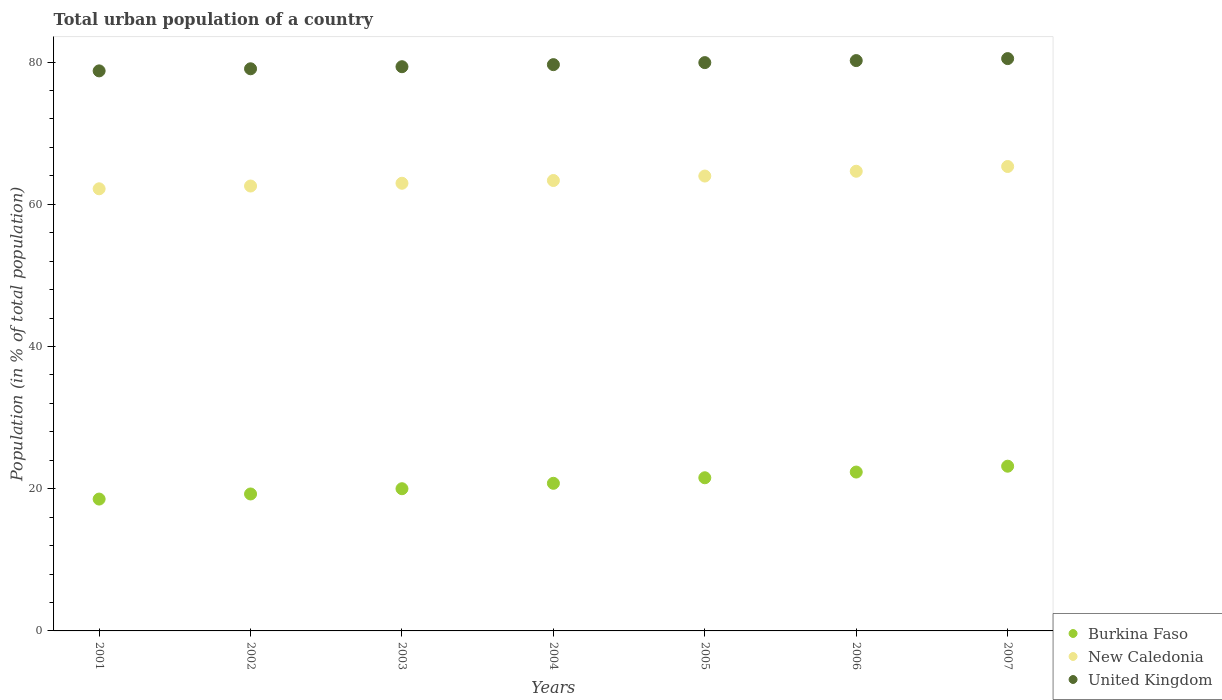How many different coloured dotlines are there?
Keep it short and to the point. 3. Is the number of dotlines equal to the number of legend labels?
Keep it short and to the point. Yes. What is the urban population in Burkina Faso in 2006?
Give a very brief answer. 22.34. Across all years, what is the maximum urban population in New Caledonia?
Provide a short and direct response. 65.31. Across all years, what is the minimum urban population in New Caledonia?
Give a very brief answer. 62.17. What is the total urban population in United Kingdom in the graph?
Your answer should be compact. 557.36. What is the difference between the urban population in United Kingdom in 2005 and that in 2007?
Give a very brief answer. -0.56. What is the difference between the urban population in United Kingdom in 2001 and the urban population in New Caledonia in 2007?
Your answer should be compact. 13.45. What is the average urban population in New Caledonia per year?
Your answer should be compact. 63.56. In the year 2003, what is the difference between the urban population in Burkina Faso and urban population in United Kingdom?
Give a very brief answer. -59.34. In how many years, is the urban population in New Caledonia greater than 72 %?
Your answer should be very brief. 0. What is the ratio of the urban population in Burkina Faso in 2002 to that in 2007?
Keep it short and to the point. 0.83. What is the difference between the highest and the second highest urban population in United Kingdom?
Ensure brevity in your answer.  0.28. What is the difference between the highest and the lowest urban population in New Caledonia?
Your answer should be very brief. 3.13. Is it the case that in every year, the sum of the urban population in Burkina Faso and urban population in United Kingdom  is greater than the urban population in New Caledonia?
Offer a terse response. Yes. Is the urban population in United Kingdom strictly greater than the urban population in New Caledonia over the years?
Your answer should be compact. Yes. Are the values on the major ticks of Y-axis written in scientific E-notation?
Ensure brevity in your answer.  No. How many legend labels are there?
Make the answer very short. 3. What is the title of the graph?
Your answer should be very brief. Total urban population of a country. What is the label or title of the X-axis?
Provide a succinct answer. Years. What is the label or title of the Y-axis?
Keep it short and to the point. Population (in % of total population). What is the Population (in % of total population) in Burkina Faso in 2001?
Ensure brevity in your answer.  18.54. What is the Population (in % of total population) in New Caledonia in 2001?
Provide a succinct answer. 62.17. What is the Population (in % of total population) in United Kingdom in 2001?
Provide a short and direct response. 78.75. What is the Population (in % of total population) in Burkina Faso in 2002?
Make the answer very short. 19.26. What is the Population (in % of total population) in New Caledonia in 2002?
Offer a terse response. 62.56. What is the Population (in % of total population) of United Kingdom in 2002?
Provide a succinct answer. 79.05. What is the Population (in % of total population) of Burkina Faso in 2003?
Provide a short and direct response. 20. What is the Population (in % of total population) of New Caledonia in 2003?
Your answer should be very brief. 62.95. What is the Population (in % of total population) of United Kingdom in 2003?
Your answer should be compact. 79.34. What is the Population (in % of total population) in Burkina Faso in 2004?
Give a very brief answer. 20.76. What is the Population (in % of total population) in New Caledonia in 2004?
Offer a terse response. 63.34. What is the Population (in % of total population) in United Kingdom in 2004?
Give a very brief answer. 79.63. What is the Population (in % of total population) in Burkina Faso in 2005?
Ensure brevity in your answer.  21.54. What is the Population (in % of total population) in New Caledonia in 2005?
Make the answer very short. 63.97. What is the Population (in % of total population) of United Kingdom in 2005?
Keep it short and to the point. 79.92. What is the Population (in % of total population) of Burkina Faso in 2006?
Provide a short and direct response. 22.34. What is the Population (in % of total population) of New Caledonia in 2006?
Offer a terse response. 64.64. What is the Population (in % of total population) of United Kingdom in 2006?
Your answer should be compact. 80.2. What is the Population (in % of total population) in Burkina Faso in 2007?
Your response must be concise. 23.16. What is the Population (in % of total population) in New Caledonia in 2007?
Give a very brief answer. 65.31. What is the Population (in % of total population) in United Kingdom in 2007?
Your answer should be very brief. 80.48. Across all years, what is the maximum Population (in % of total population) of Burkina Faso?
Keep it short and to the point. 23.16. Across all years, what is the maximum Population (in % of total population) in New Caledonia?
Provide a succinct answer. 65.31. Across all years, what is the maximum Population (in % of total population) of United Kingdom?
Your response must be concise. 80.48. Across all years, what is the minimum Population (in % of total population) of Burkina Faso?
Your answer should be compact. 18.54. Across all years, what is the minimum Population (in % of total population) of New Caledonia?
Offer a very short reply. 62.17. Across all years, what is the minimum Population (in % of total population) of United Kingdom?
Make the answer very short. 78.75. What is the total Population (in % of total population) of Burkina Faso in the graph?
Ensure brevity in your answer.  145.59. What is the total Population (in % of total population) of New Caledonia in the graph?
Your answer should be very brief. 444.93. What is the total Population (in % of total population) in United Kingdom in the graph?
Your answer should be very brief. 557.36. What is the difference between the Population (in % of total population) in Burkina Faso in 2001 and that in 2002?
Make the answer very short. -0.72. What is the difference between the Population (in % of total population) in New Caledonia in 2001 and that in 2002?
Your answer should be compact. -0.39. What is the difference between the Population (in % of total population) in United Kingdom in 2001 and that in 2002?
Offer a very short reply. -0.3. What is the difference between the Population (in % of total population) of Burkina Faso in 2001 and that in 2003?
Provide a succinct answer. -1.46. What is the difference between the Population (in % of total population) in New Caledonia in 2001 and that in 2003?
Give a very brief answer. -0.78. What is the difference between the Population (in % of total population) of United Kingdom in 2001 and that in 2003?
Keep it short and to the point. -0.59. What is the difference between the Population (in % of total population) in Burkina Faso in 2001 and that in 2004?
Give a very brief answer. -2.22. What is the difference between the Population (in % of total population) in New Caledonia in 2001 and that in 2004?
Your answer should be very brief. -1.17. What is the difference between the Population (in % of total population) in United Kingdom in 2001 and that in 2004?
Keep it short and to the point. -0.88. What is the difference between the Population (in % of total population) of Burkina Faso in 2001 and that in 2005?
Offer a terse response. -3. What is the difference between the Population (in % of total population) in New Caledonia in 2001 and that in 2005?
Make the answer very short. -1.79. What is the difference between the Population (in % of total population) in United Kingdom in 2001 and that in 2005?
Offer a very short reply. -1.16. What is the difference between the Population (in % of total population) in Burkina Faso in 2001 and that in 2006?
Your answer should be very brief. -3.8. What is the difference between the Population (in % of total population) in New Caledonia in 2001 and that in 2006?
Make the answer very short. -2.47. What is the difference between the Population (in % of total population) in United Kingdom in 2001 and that in 2006?
Ensure brevity in your answer.  -1.45. What is the difference between the Population (in % of total population) of Burkina Faso in 2001 and that in 2007?
Keep it short and to the point. -4.62. What is the difference between the Population (in % of total population) in New Caledonia in 2001 and that in 2007?
Keep it short and to the point. -3.13. What is the difference between the Population (in % of total population) of United Kingdom in 2001 and that in 2007?
Provide a short and direct response. -1.73. What is the difference between the Population (in % of total population) in Burkina Faso in 2002 and that in 2003?
Offer a terse response. -0.74. What is the difference between the Population (in % of total population) of New Caledonia in 2002 and that in 2003?
Offer a terse response. -0.39. What is the difference between the Population (in % of total population) of United Kingdom in 2002 and that in 2003?
Your answer should be compact. -0.29. What is the difference between the Population (in % of total population) of Burkina Faso in 2002 and that in 2004?
Your answer should be very brief. -1.5. What is the difference between the Population (in % of total population) in New Caledonia in 2002 and that in 2004?
Ensure brevity in your answer.  -0.78. What is the difference between the Population (in % of total population) of United Kingdom in 2002 and that in 2004?
Give a very brief answer. -0.58. What is the difference between the Population (in % of total population) in Burkina Faso in 2002 and that in 2005?
Your response must be concise. -2.28. What is the difference between the Population (in % of total population) in New Caledonia in 2002 and that in 2005?
Your answer should be very brief. -1.4. What is the difference between the Population (in % of total population) of United Kingdom in 2002 and that in 2005?
Give a very brief answer. -0.87. What is the difference between the Population (in % of total population) of Burkina Faso in 2002 and that in 2006?
Your response must be concise. -3.08. What is the difference between the Population (in % of total population) of New Caledonia in 2002 and that in 2006?
Provide a short and direct response. -2.08. What is the difference between the Population (in % of total population) in United Kingdom in 2002 and that in 2006?
Your answer should be compact. -1.15. What is the difference between the Population (in % of total population) of Burkina Faso in 2002 and that in 2007?
Provide a succinct answer. -3.9. What is the difference between the Population (in % of total population) of New Caledonia in 2002 and that in 2007?
Your response must be concise. -2.75. What is the difference between the Population (in % of total population) in United Kingdom in 2002 and that in 2007?
Offer a terse response. -1.43. What is the difference between the Population (in % of total population) in Burkina Faso in 2003 and that in 2004?
Your response must be concise. -0.76. What is the difference between the Population (in % of total population) in New Caledonia in 2003 and that in 2004?
Offer a terse response. -0.39. What is the difference between the Population (in % of total population) in United Kingdom in 2003 and that in 2004?
Make the answer very short. -0.29. What is the difference between the Population (in % of total population) in Burkina Faso in 2003 and that in 2005?
Give a very brief answer. -1.54. What is the difference between the Population (in % of total population) in New Caledonia in 2003 and that in 2005?
Your answer should be very brief. -1.02. What is the difference between the Population (in % of total population) of United Kingdom in 2003 and that in 2005?
Make the answer very short. -0.58. What is the difference between the Population (in % of total population) in Burkina Faso in 2003 and that in 2006?
Keep it short and to the point. -2.34. What is the difference between the Population (in % of total population) of New Caledonia in 2003 and that in 2006?
Offer a terse response. -1.69. What is the difference between the Population (in % of total population) of United Kingdom in 2003 and that in 2006?
Give a very brief answer. -0.86. What is the difference between the Population (in % of total population) of Burkina Faso in 2003 and that in 2007?
Keep it short and to the point. -3.17. What is the difference between the Population (in % of total population) of New Caledonia in 2003 and that in 2007?
Offer a terse response. -2.36. What is the difference between the Population (in % of total population) of United Kingdom in 2003 and that in 2007?
Offer a terse response. -1.14. What is the difference between the Population (in % of total population) in Burkina Faso in 2004 and that in 2005?
Your answer should be compact. -0.78. What is the difference between the Population (in % of total population) of New Caledonia in 2004 and that in 2005?
Your answer should be very brief. -0.63. What is the difference between the Population (in % of total population) in United Kingdom in 2004 and that in 2005?
Your response must be concise. -0.29. What is the difference between the Population (in % of total population) in Burkina Faso in 2004 and that in 2006?
Your answer should be compact. -1.58. What is the difference between the Population (in % of total population) of New Caledonia in 2004 and that in 2006?
Your answer should be compact. -1.3. What is the difference between the Population (in % of total population) of United Kingdom in 2004 and that in 2006?
Provide a short and direct response. -0.57. What is the difference between the Population (in % of total population) in Burkina Faso in 2004 and that in 2007?
Offer a very short reply. -2.41. What is the difference between the Population (in % of total population) of New Caledonia in 2004 and that in 2007?
Offer a terse response. -1.97. What is the difference between the Population (in % of total population) of United Kingdom in 2004 and that in 2007?
Your answer should be very brief. -0.85. What is the difference between the Population (in % of total population) in Burkina Faso in 2005 and that in 2006?
Offer a terse response. -0.8. What is the difference between the Population (in % of total population) in New Caledonia in 2005 and that in 2006?
Offer a very short reply. -0.67. What is the difference between the Population (in % of total population) in United Kingdom in 2005 and that in 2006?
Offer a terse response. -0.28. What is the difference between the Population (in % of total population) of Burkina Faso in 2005 and that in 2007?
Provide a succinct answer. -1.63. What is the difference between the Population (in % of total population) of New Caledonia in 2005 and that in 2007?
Your answer should be very brief. -1.34. What is the difference between the Population (in % of total population) in United Kingdom in 2005 and that in 2007?
Provide a short and direct response. -0.56. What is the difference between the Population (in % of total population) of Burkina Faso in 2006 and that in 2007?
Offer a very short reply. -0.82. What is the difference between the Population (in % of total population) in New Caledonia in 2006 and that in 2007?
Keep it short and to the point. -0.67. What is the difference between the Population (in % of total population) of United Kingdom in 2006 and that in 2007?
Keep it short and to the point. -0.28. What is the difference between the Population (in % of total population) in Burkina Faso in 2001 and the Population (in % of total population) in New Caledonia in 2002?
Offer a very short reply. -44.02. What is the difference between the Population (in % of total population) in Burkina Faso in 2001 and the Population (in % of total population) in United Kingdom in 2002?
Offer a very short reply. -60.51. What is the difference between the Population (in % of total population) in New Caledonia in 2001 and the Population (in % of total population) in United Kingdom in 2002?
Make the answer very short. -16.88. What is the difference between the Population (in % of total population) in Burkina Faso in 2001 and the Population (in % of total population) in New Caledonia in 2003?
Offer a terse response. -44.41. What is the difference between the Population (in % of total population) in Burkina Faso in 2001 and the Population (in % of total population) in United Kingdom in 2003?
Make the answer very short. -60.8. What is the difference between the Population (in % of total population) in New Caledonia in 2001 and the Population (in % of total population) in United Kingdom in 2003?
Offer a terse response. -17.17. What is the difference between the Population (in % of total population) of Burkina Faso in 2001 and the Population (in % of total population) of New Caledonia in 2004?
Offer a very short reply. -44.8. What is the difference between the Population (in % of total population) of Burkina Faso in 2001 and the Population (in % of total population) of United Kingdom in 2004?
Your answer should be compact. -61.09. What is the difference between the Population (in % of total population) in New Caledonia in 2001 and the Population (in % of total population) in United Kingdom in 2004?
Your answer should be compact. -17.46. What is the difference between the Population (in % of total population) of Burkina Faso in 2001 and the Population (in % of total population) of New Caledonia in 2005?
Ensure brevity in your answer.  -45.42. What is the difference between the Population (in % of total population) in Burkina Faso in 2001 and the Population (in % of total population) in United Kingdom in 2005?
Your answer should be compact. -61.38. What is the difference between the Population (in % of total population) of New Caledonia in 2001 and the Population (in % of total population) of United Kingdom in 2005?
Keep it short and to the point. -17.74. What is the difference between the Population (in % of total population) in Burkina Faso in 2001 and the Population (in % of total population) in New Caledonia in 2006?
Ensure brevity in your answer.  -46.1. What is the difference between the Population (in % of total population) of Burkina Faso in 2001 and the Population (in % of total population) of United Kingdom in 2006?
Your response must be concise. -61.66. What is the difference between the Population (in % of total population) in New Caledonia in 2001 and the Population (in % of total population) in United Kingdom in 2006?
Provide a short and direct response. -18.03. What is the difference between the Population (in % of total population) of Burkina Faso in 2001 and the Population (in % of total population) of New Caledonia in 2007?
Ensure brevity in your answer.  -46.77. What is the difference between the Population (in % of total population) of Burkina Faso in 2001 and the Population (in % of total population) of United Kingdom in 2007?
Ensure brevity in your answer.  -61.94. What is the difference between the Population (in % of total population) in New Caledonia in 2001 and the Population (in % of total population) in United Kingdom in 2007?
Offer a terse response. -18.31. What is the difference between the Population (in % of total population) in Burkina Faso in 2002 and the Population (in % of total population) in New Caledonia in 2003?
Offer a terse response. -43.69. What is the difference between the Population (in % of total population) of Burkina Faso in 2002 and the Population (in % of total population) of United Kingdom in 2003?
Keep it short and to the point. -60.08. What is the difference between the Population (in % of total population) in New Caledonia in 2002 and the Population (in % of total population) in United Kingdom in 2003?
Your answer should be compact. -16.78. What is the difference between the Population (in % of total population) of Burkina Faso in 2002 and the Population (in % of total population) of New Caledonia in 2004?
Ensure brevity in your answer.  -44.08. What is the difference between the Population (in % of total population) of Burkina Faso in 2002 and the Population (in % of total population) of United Kingdom in 2004?
Your answer should be compact. -60.37. What is the difference between the Population (in % of total population) in New Caledonia in 2002 and the Population (in % of total population) in United Kingdom in 2004?
Offer a terse response. -17.07. What is the difference between the Population (in % of total population) of Burkina Faso in 2002 and the Population (in % of total population) of New Caledonia in 2005?
Your answer should be compact. -44.71. What is the difference between the Population (in % of total population) of Burkina Faso in 2002 and the Population (in % of total population) of United Kingdom in 2005?
Your answer should be compact. -60.66. What is the difference between the Population (in % of total population) in New Caledonia in 2002 and the Population (in % of total population) in United Kingdom in 2005?
Your response must be concise. -17.35. What is the difference between the Population (in % of total population) of Burkina Faso in 2002 and the Population (in % of total population) of New Caledonia in 2006?
Provide a succinct answer. -45.38. What is the difference between the Population (in % of total population) in Burkina Faso in 2002 and the Population (in % of total population) in United Kingdom in 2006?
Offer a terse response. -60.94. What is the difference between the Population (in % of total population) in New Caledonia in 2002 and the Population (in % of total population) in United Kingdom in 2006?
Your response must be concise. -17.64. What is the difference between the Population (in % of total population) in Burkina Faso in 2002 and the Population (in % of total population) in New Caledonia in 2007?
Ensure brevity in your answer.  -46.05. What is the difference between the Population (in % of total population) in Burkina Faso in 2002 and the Population (in % of total population) in United Kingdom in 2007?
Your answer should be compact. -61.22. What is the difference between the Population (in % of total population) of New Caledonia in 2002 and the Population (in % of total population) of United Kingdom in 2007?
Provide a succinct answer. -17.92. What is the difference between the Population (in % of total population) in Burkina Faso in 2003 and the Population (in % of total population) in New Caledonia in 2004?
Offer a terse response. -43.34. What is the difference between the Population (in % of total population) of Burkina Faso in 2003 and the Population (in % of total population) of United Kingdom in 2004?
Keep it short and to the point. -59.63. What is the difference between the Population (in % of total population) of New Caledonia in 2003 and the Population (in % of total population) of United Kingdom in 2004?
Your response must be concise. -16.68. What is the difference between the Population (in % of total population) of Burkina Faso in 2003 and the Population (in % of total population) of New Caledonia in 2005?
Provide a succinct answer. -43.97. What is the difference between the Population (in % of total population) in Burkina Faso in 2003 and the Population (in % of total population) in United Kingdom in 2005?
Your response must be concise. -59.92. What is the difference between the Population (in % of total population) of New Caledonia in 2003 and the Population (in % of total population) of United Kingdom in 2005?
Your answer should be very brief. -16.97. What is the difference between the Population (in % of total population) of Burkina Faso in 2003 and the Population (in % of total population) of New Caledonia in 2006?
Make the answer very short. -44.64. What is the difference between the Population (in % of total population) in Burkina Faso in 2003 and the Population (in % of total population) in United Kingdom in 2006?
Offer a very short reply. -60.2. What is the difference between the Population (in % of total population) of New Caledonia in 2003 and the Population (in % of total population) of United Kingdom in 2006?
Your answer should be compact. -17.25. What is the difference between the Population (in % of total population) in Burkina Faso in 2003 and the Population (in % of total population) in New Caledonia in 2007?
Offer a very short reply. -45.31. What is the difference between the Population (in % of total population) of Burkina Faso in 2003 and the Population (in % of total population) of United Kingdom in 2007?
Give a very brief answer. -60.48. What is the difference between the Population (in % of total population) of New Caledonia in 2003 and the Population (in % of total population) of United Kingdom in 2007?
Keep it short and to the point. -17.53. What is the difference between the Population (in % of total population) of Burkina Faso in 2004 and the Population (in % of total population) of New Caledonia in 2005?
Provide a short and direct response. -43.21. What is the difference between the Population (in % of total population) in Burkina Faso in 2004 and the Population (in % of total population) in United Kingdom in 2005?
Keep it short and to the point. -59.16. What is the difference between the Population (in % of total population) of New Caledonia in 2004 and the Population (in % of total population) of United Kingdom in 2005?
Keep it short and to the point. -16.58. What is the difference between the Population (in % of total population) in Burkina Faso in 2004 and the Population (in % of total population) in New Caledonia in 2006?
Your response must be concise. -43.88. What is the difference between the Population (in % of total population) of Burkina Faso in 2004 and the Population (in % of total population) of United Kingdom in 2006?
Provide a succinct answer. -59.44. What is the difference between the Population (in % of total population) in New Caledonia in 2004 and the Population (in % of total population) in United Kingdom in 2006?
Make the answer very short. -16.86. What is the difference between the Population (in % of total population) of Burkina Faso in 2004 and the Population (in % of total population) of New Caledonia in 2007?
Offer a terse response. -44.55. What is the difference between the Population (in % of total population) in Burkina Faso in 2004 and the Population (in % of total population) in United Kingdom in 2007?
Offer a very short reply. -59.72. What is the difference between the Population (in % of total population) of New Caledonia in 2004 and the Population (in % of total population) of United Kingdom in 2007?
Make the answer very short. -17.14. What is the difference between the Population (in % of total population) of Burkina Faso in 2005 and the Population (in % of total population) of New Caledonia in 2006?
Offer a terse response. -43.1. What is the difference between the Population (in % of total population) of Burkina Faso in 2005 and the Population (in % of total population) of United Kingdom in 2006?
Ensure brevity in your answer.  -58.66. What is the difference between the Population (in % of total population) of New Caledonia in 2005 and the Population (in % of total population) of United Kingdom in 2006?
Provide a succinct answer. -16.23. What is the difference between the Population (in % of total population) in Burkina Faso in 2005 and the Population (in % of total population) in New Caledonia in 2007?
Give a very brief answer. -43.77. What is the difference between the Population (in % of total population) of Burkina Faso in 2005 and the Population (in % of total population) of United Kingdom in 2007?
Make the answer very short. -58.94. What is the difference between the Population (in % of total population) in New Caledonia in 2005 and the Population (in % of total population) in United Kingdom in 2007?
Give a very brief answer. -16.51. What is the difference between the Population (in % of total population) in Burkina Faso in 2006 and the Population (in % of total population) in New Caledonia in 2007?
Give a very brief answer. -42.97. What is the difference between the Population (in % of total population) of Burkina Faso in 2006 and the Population (in % of total population) of United Kingdom in 2007?
Offer a terse response. -58.14. What is the difference between the Population (in % of total population) of New Caledonia in 2006 and the Population (in % of total population) of United Kingdom in 2007?
Make the answer very short. -15.84. What is the average Population (in % of total population) in Burkina Faso per year?
Your response must be concise. 20.8. What is the average Population (in % of total population) of New Caledonia per year?
Give a very brief answer. 63.56. What is the average Population (in % of total population) in United Kingdom per year?
Make the answer very short. 79.62. In the year 2001, what is the difference between the Population (in % of total population) in Burkina Faso and Population (in % of total population) in New Caledonia?
Your answer should be very brief. -43.63. In the year 2001, what is the difference between the Population (in % of total population) of Burkina Faso and Population (in % of total population) of United Kingdom?
Provide a short and direct response. -60.21. In the year 2001, what is the difference between the Population (in % of total population) in New Caledonia and Population (in % of total population) in United Kingdom?
Keep it short and to the point. -16.58. In the year 2002, what is the difference between the Population (in % of total population) of Burkina Faso and Population (in % of total population) of New Caledonia?
Offer a terse response. -43.3. In the year 2002, what is the difference between the Population (in % of total population) in Burkina Faso and Population (in % of total population) in United Kingdom?
Keep it short and to the point. -59.79. In the year 2002, what is the difference between the Population (in % of total population) in New Caledonia and Population (in % of total population) in United Kingdom?
Offer a terse response. -16.49. In the year 2003, what is the difference between the Population (in % of total population) in Burkina Faso and Population (in % of total population) in New Caledonia?
Provide a short and direct response. -42.95. In the year 2003, what is the difference between the Population (in % of total population) in Burkina Faso and Population (in % of total population) in United Kingdom?
Keep it short and to the point. -59.34. In the year 2003, what is the difference between the Population (in % of total population) of New Caledonia and Population (in % of total population) of United Kingdom?
Your answer should be very brief. -16.39. In the year 2004, what is the difference between the Population (in % of total population) in Burkina Faso and Population (in % of total population) in New Caledonia?
Offer a terse response. -42.58. In the year 2004, what is the difference between the Population (in % of total population) in Burkina Faso and Population (in % of total population) in United Kingdom?
Your response must be concise. -58.87. In the year 2004, what is the difference between the Population (in % of total population) in New Caledonia and Population (in % of total population) in United Kingdom?
Your answer should be compact. -16.29. In the year 2005, what is the difference between the Population (in % of total population) of Burkina Faso and Population (in % of total population) of New Caledonia?
Offer a terse response. -42.43. In the year 2005, what is the difference between the Population (in % of total population) in Burkina Faso and Population (in % of total population) in United Kingdom?
Provide a succinct answer. -58.38. In the year 2005, what is the difference between the Population (in % of total population) in New Caledonia and Population (in % of total population) in United Kingdom?
Your answer should be very brief. -15.95. In the year 2006, what is the difference between the Population (in % of total population) in Burkina Faso and Population (in % of total population) in New Caledonia?
Offer a terse response. -42.3. In the year 2006, what is the difference between the Population (in % of total population) in Burkina Faso and Population (in % of total population) in United Kingdom?
Your answer should be very brief. -57.86. In the year 2006, what is the difference between the Population (in % of total population) of New Caledonia and Population (in % of total population) of United Kingdom?
Your answer should be compact. -15.56. In the year 2007, what is the difference between the Population (in % of total population) of Burkina Faso and Population (in % of total population) of New Caledonia?
Offer a terse response. -42.14. In the year 2007, what is the difference between the Population (in % of total population) of Burkina Faso and Population (in % of total population) of United Kingdom?
Your response must be concise. -57.32. In the year 2007, what is the difference between the Population (in % of total population) in New Caledonia and Population (in % of total population) in United Kingdom?
Ensure brevity in your answer.  -15.17. What is the ratio of the Population (in % of total population) of Burkina Faso in 2001 to that in 2002?
Offer a terse response. 0.96. What is the ratio of the Population (in % of total population) of Burkina Faso in 2001 to that in 2003?
Provide a succinct answer. 0.93. What is the ratio of the Population (in % of total population) of New Caledonia in 2001 to that in 2003?
Make the answer very short. 0.99. What is the ratio of the Population (in % of total population) in Burkina Faso in 2001 to that in 2004?
Your answer should be compact. 0.89. What is the ratio of the Population (in % of total population) in New Caledonia in 2001 to that in 2004?
Give a very brief answer. 0.98. What is the ratio of the Population (in % of total population) in Burkina Faso in 2001 to that in 2005?
Ensure brevity in your answer.  0.86. What is the ratio of the Population (in % of total population) of United Kingdom in 2001 to that in 2005?
Offer a terse response. 0.99. What is the ratio of the Population (in % of total population) of Burkina Faso in 2001 to that in 2006?
Provide a short and direct response. 0.83. What is the ratio of the Population (in % of total population) in New Caledonia in 2001 to that in 2006?
Your answer should be compact. 0.96. What is the ratio of the Population (in % of total population) in United Kingdom in 2001 to that in 2006?
Make the answer very short. 0.98. What is the ratio of the Population (in % of total population) of Burkina Faso in 2001 to that in 2007?
Provide a succinct answer. 0.8. What is the ratio of the Population (in % of total population) in New Caledonia in 2001 to that in 2007?
Your answer should be very brief. 0.95. What is the ratio of the Population (in % of total population) in United Kingdom in 2001 to that in 2007?
Your response must be concise. 0.98. What is the ratio of the Population (in % of total population) of Burkina Faso in 2002 to that in 2003?
Make the answer very short. 0.96. What is the ratio of the Population (in % of total population) of New Caledonia in 2002 to that in 2003?
Make the answer very short. 0.99. What is the ratio of the Population (in % of total population) of United Kingdom in 2002 to that in 2003?
Give a very brief answer. 1. What is the ratio of the Population (in % of total population) in Burkina Faso in 2002 to that in 2004?
Provide a succinct answer. 0.93. What is the ratio of the Population (in % of total population) of Burkina Faso in 2002 to that in 2005?
Provide a succinct answer. 0.89. What is the ratio of the Population (in % of total population) of New Caledonia in 2002 to that in 2005?
Provide a short and direct response. 0.98. What is the ratio of the Population (in % of total population) in Burkina Faso in 2002 to that in 2006?
Offer a very short reply. 0.86. What is the ratio of the Population (in % of total population) in New Caledonia in 2002 to that in 2006?
Your response must be concise. 0.97. What is the ratio of the Population (in % of total population) in United Kingdom in 2002 to that in 2006?
Offer a terse response. 0.99. What is the ratio of the Population (in % of total population) of Burkina Faso in 2002 to that in 2007?
Your response must be concise. 0.83. What is the ratio of the Population (in % of total population) of New Caledonia in 2002 to that in 2007?
Your response must be concise. 0.96. What is the ratio of the Population (in % of total population) of United Kingdom in 2002 to that in 2007?
Provide a succinct answer. 0.98. What is the ratio of the Population (in % of total population) of Burkina Faso in 2003 to that in 2004?
Provide a short and direct response. 0.96. What is the ratio of the Population (in % of total population) in Burkina Faso in 2003 to that in 2005?
Your response must be concise. 0.93. What is the ratio of the Population (in % of total population) of New Caledonia in 2003 to that in 2005?
Give a very brief answer. 0.98. What is the ratio of the Population (in % of total population) of United Kingdom in 2003 to that in 2005?
Make the answer very short. 0.99. What is the ratio of the Population (in % of total population) of Burkina Faso in 2003 to that in 2006?
Provide a short and direct response. 0.9. What is the ratio of the Population (in % of total population) in New Caledonia in 2003 to that in 2006?
Give a very brief answer. 0.97. What is the ratio of the Population (in % of total population) of United Kingdom in 2003 to that in 2006?
Provide a short and direct response. 0.99. What is the ratio of the Population (in % of total population) of Burkina Faso in 2003 to that in 2007?
Ensure brevity in your answer.  0.86. What is the ratio of the Population (in % of total population) in New Caledonia in 2003 to that in 2007?
Make the answer very short. 0.96. What is the ratio of the Population (in % of total population) of United Kingdom in 2003 to that in 2007?
Ensure brevity in your answer.  0.99. What is the ratio of the Population (in % of total population) in Burkina Faso in 2004 to that in 2005?
Provide a succinct answer. 0.96. What is the ratio of the Population (in % of total population) in New Caledonia in 2004 to that in 2005?
Make the answer very short. 0.99. What is the ratio of the Population (in % of total population) in United Kingdom in 2004 to that in 2005?
Give a very brief answer. 1. What is the ratio of the Population (in % of total population) in Burkina Faso in 2004 to that in 2006?
Offer a terse response. 0.93. What is the ratio of the Population (in % of total population) in New Caledonia in 2004 to that in 2006?
Provide a short and direct response. 0.98. What is the ratio of the Population (in % of total population) of Burkina Faso in 2004 to that in 2007?
Offer a very short reply. 0.9. What is the ratio of the Population (in % of total population) in New Caledonia in 2004 to that in 2007?
Keep it short and to the point. 0.97. What is the ratio of the Population (in % of total population) in United Kingdom in 2004 to that in 2007?
Give a very brief answer. 0.99. What is the ratio of the Population (in % of total population) of Burkina Faso in 2005 to that in 2006?
Offer a terse response. 0.96. What is the ratio of the Population (in % of total population) in United Kingdom in 2005 to that in 2006?
Your answer should be very brief. 1. What is the ratio of the Population (in % of total population) of Burkina Faso in 2005 to that in 2007?
Your answer should be compact. 0.93. What is the ratio of the Population (in % of total population) of New Caledonia in 2005 to that in 2007?
Make the answer very short. 0.98. What is the ratio of the Population (in % of total population) of United Kingdom in 2005 to that in 2007?
Provide a short and direct response. 0.99. What is the ratio of the Population (in % of total population) of Burkina Faso in 2006 to that in 2007?
Your answer should be compact. 0.96. What is the difference between the highest and the second highest Population (in % of total population) in Burkina Faso?
Provide a short and direct response. 0.82. What is the difference between the highest and the second highest Population (in % of total population) of New Caledonia?
Your answer should be very brief. 0.67. What is the difference between the highest and the second highest Population (in % of total population) of United Kingdom?
Keep it short and to the point. 0.28. What is the difference between the highest and the lowest Population (in % of total population) of Burkina Faso?
Ensure brevity in your answer.  4.62. What is the difference between the highest and the lowest Population (in % of total population) in New Caledonia?
Offer a terse response. 3.13. What is the difference between the highest and the lowest Population (in % of total population) in United Kingdom?
Make the answer very short. 1.73. 